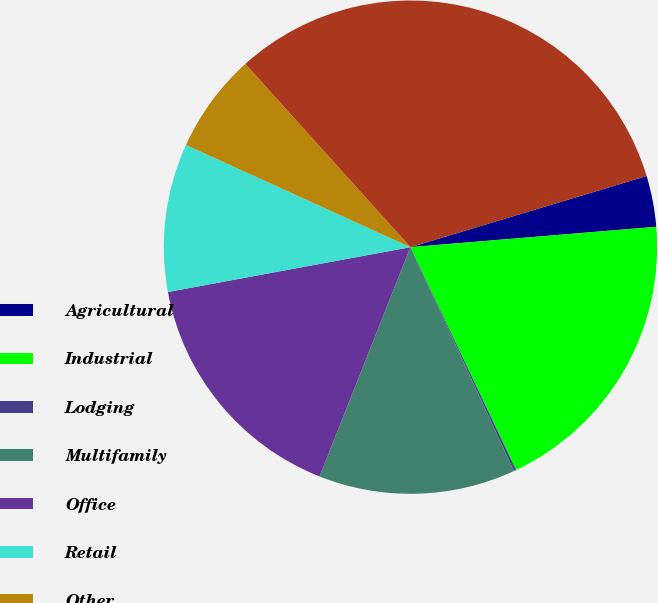<chart> <loc_0><loc_0><loc_500><loc_500><pie_chart><fcel>Agricultural<fcel>Industrial<fcel>Lodging<fcel>Multifamily<fcel>Office<fcel>Retail<fcel>Other<fcel>Total mortgage loans<nl><fcel>3.34%<fcel>19.27%<fcel>0.15%<fcel>12.9%<fcel>16.08%<fcel>9.71%<fcel>6.53%<fcel>32.01%<nl></chart> 